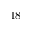<formula> <loc_0><loc_0><loc_500><loc_500>1 8</formula> 